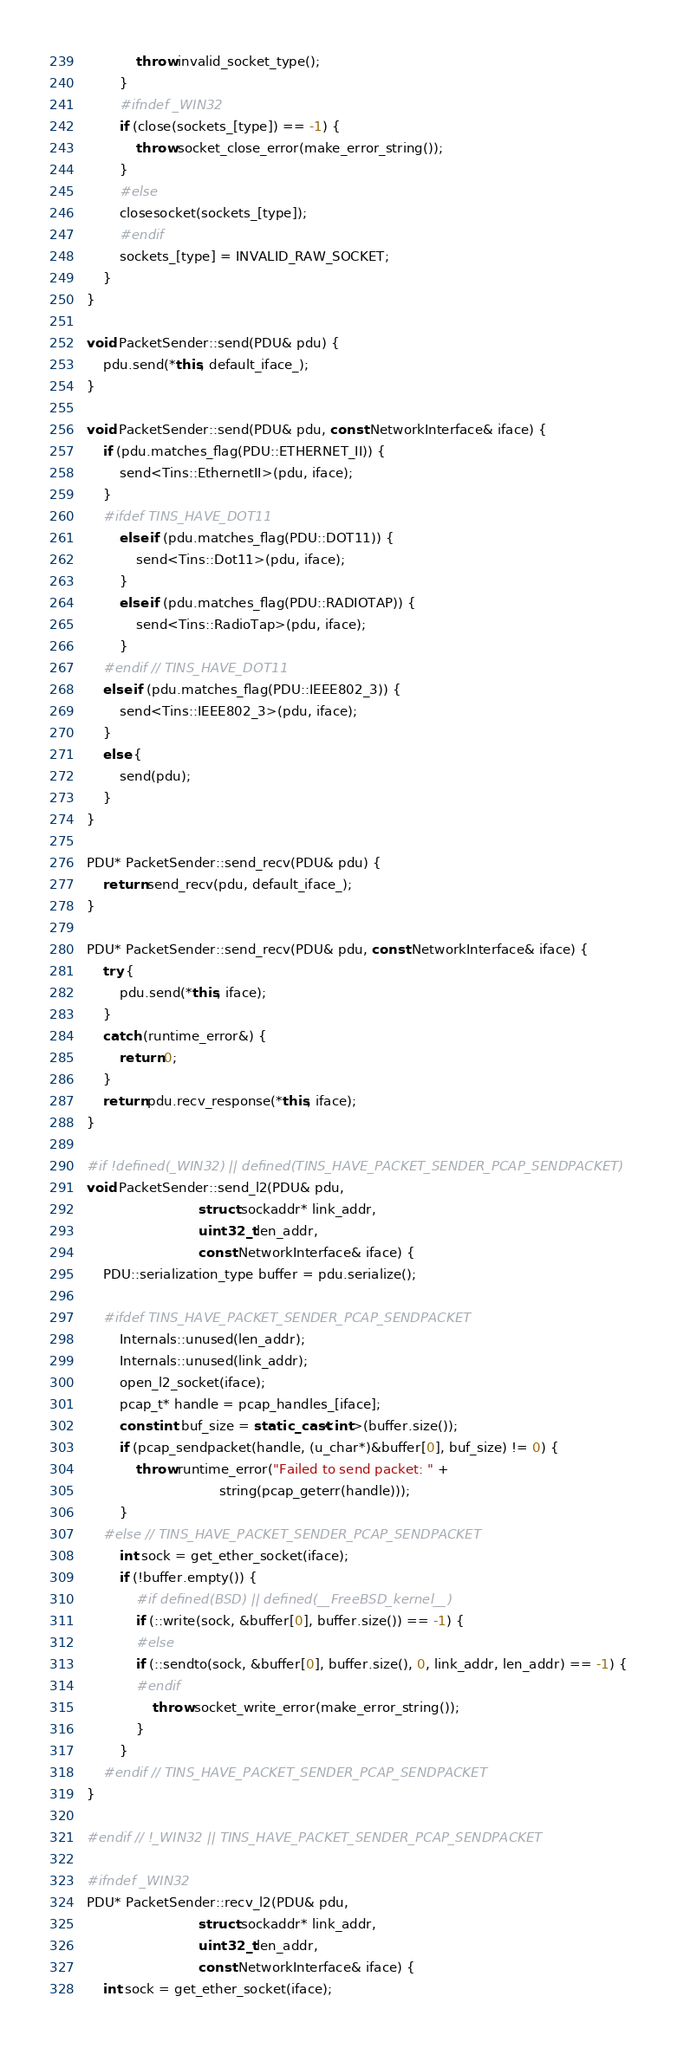<code> <loc_0><loc_0><loc_500><loc_500><_C++_>            throw invalid_socket_type();
        }
        #ifndef _WIN32
        if (close(sockets_[type]) == -1) {
            throw socket_close_error(make_error_string());
        }
        #else
        closesocket(sockets_[type]);
        #endif
        sockets_[type] = INVALID_RAW_SOCKET;
    }
}

void PacketSender::send(PDU& pdu) {
    pdu.send(*this, default_iface_);
}

void PacketSender::send(PDU& pdu, const NetworkInterface& iface) {
    if (pdu.matches_flag(PDU::ETHERNET_II)) {
        send<Tins::EthernetII>(pdu, iface);
    }
    #ifdef TINS_HAVE_DOT11
        else if (pdu.matches_flag(PDU::DOT11)) {
            send<Tins::Dot11>(pdu, iface);
        }
        else if (pdu.matches_flag(PDU::RADIOTAP)) {
            send<Tins::RadioTap>(pdu, iface);
        }
    #endif // TINS_HAVE_DOT11
    else if (pdu.matches_flag(PDU::IEEE802_3)) {
        send<Tins::IEEE802_3>(pdu, iface);
    }
    else {
        send(pdu);
    }
}

PDU* PacketSender::send_recv(PDU& pdu) {
    return send_recv(pdu, default_iface_);
}

PDU* PacketSender::send_recv(PDU& pdu, const NetworkInterface& iface) {
    try {
        pdu.send(*this, iface);
    }
    catch (runtime_error&) {
        return 0;
    }
    return pdu.recv_response(*this, iface);
}

#if !defined(_WIN32) || defined(TINS_HAVE_PACKET_SENDER_PCAP_SENDPACKET)
void PacketSender::send_l2(PDU& pdu,
                           struct sockaddr* link_addr, 
                           uint32_t len_addr,
                           const NetworkInterface& iface) {
    PDU::serialization_type buffer = pdu.serialize();

    #ifdef TINS_HAVE_PACKET_SENDER_PCAP_SENDPACKET
        Internals::unused(len_addr);
        Internals::unused(link_addr);
        open_l2_socket(iface);
        pcap_t* handle = pcap_handles_[iface];
        const int buf_size = static_cast<int>(buffer.size());
        if (pcap_sendpacket(handle, (u_char*)&buffer[0], buf_size) != 0) {
            throw runtime_error("Failed to send packet: " + 
                                string(pcap_geterr(handle)));
        }
    #else // TINS_HAVE_PACKET_SENDER_PCAP_SENDPACKET
        int sock = get_ether_socket(iface);
        if (!buffer.empty()) {
            #if defined(BSD) || defined(__FreeBSD_kernel__)
            if (::write(sock, &buffer[0], buffer.size()) == -1) {
            #else
            if (::sendto(sock, &buffer[0], buffer.size(), 0, link_addr, len_addr) == -1) {
            #endif
                throw socket_write_error(make_error_string());
            }
        }
    #endif // TINS_HAVE_PACKET_SENDER_PCAP_SENDPACKET
}

#endif // !_WIN32 || TINS_HAVE_PACKET_SENDER_PCAP_SENDPACKET

#ifndef _WIN32
PDU* PacketSender::recv_l2(PDU& pdu, 
                           struct sockaddr* link_addr, 
                           uint32_t len_addr,
                           const NetworkInterface& iface) {
    int sock = get_ether_socket(iface);</code> 